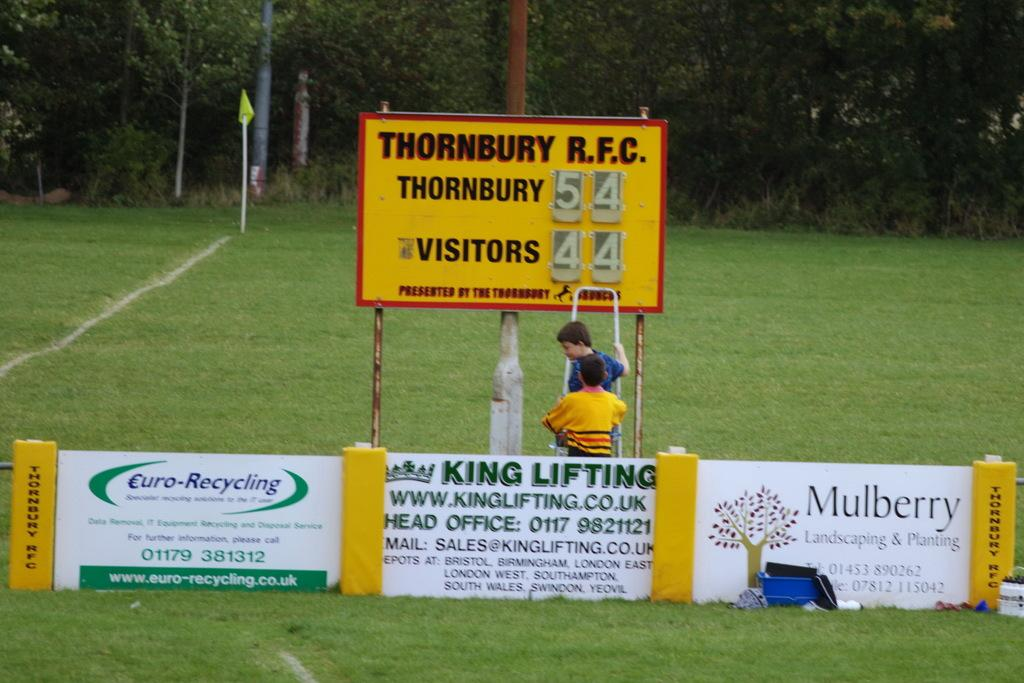<image>
Give a short and clear explanation of the subsequent image. A group of children change the score on a Thornbury RFC score card. 